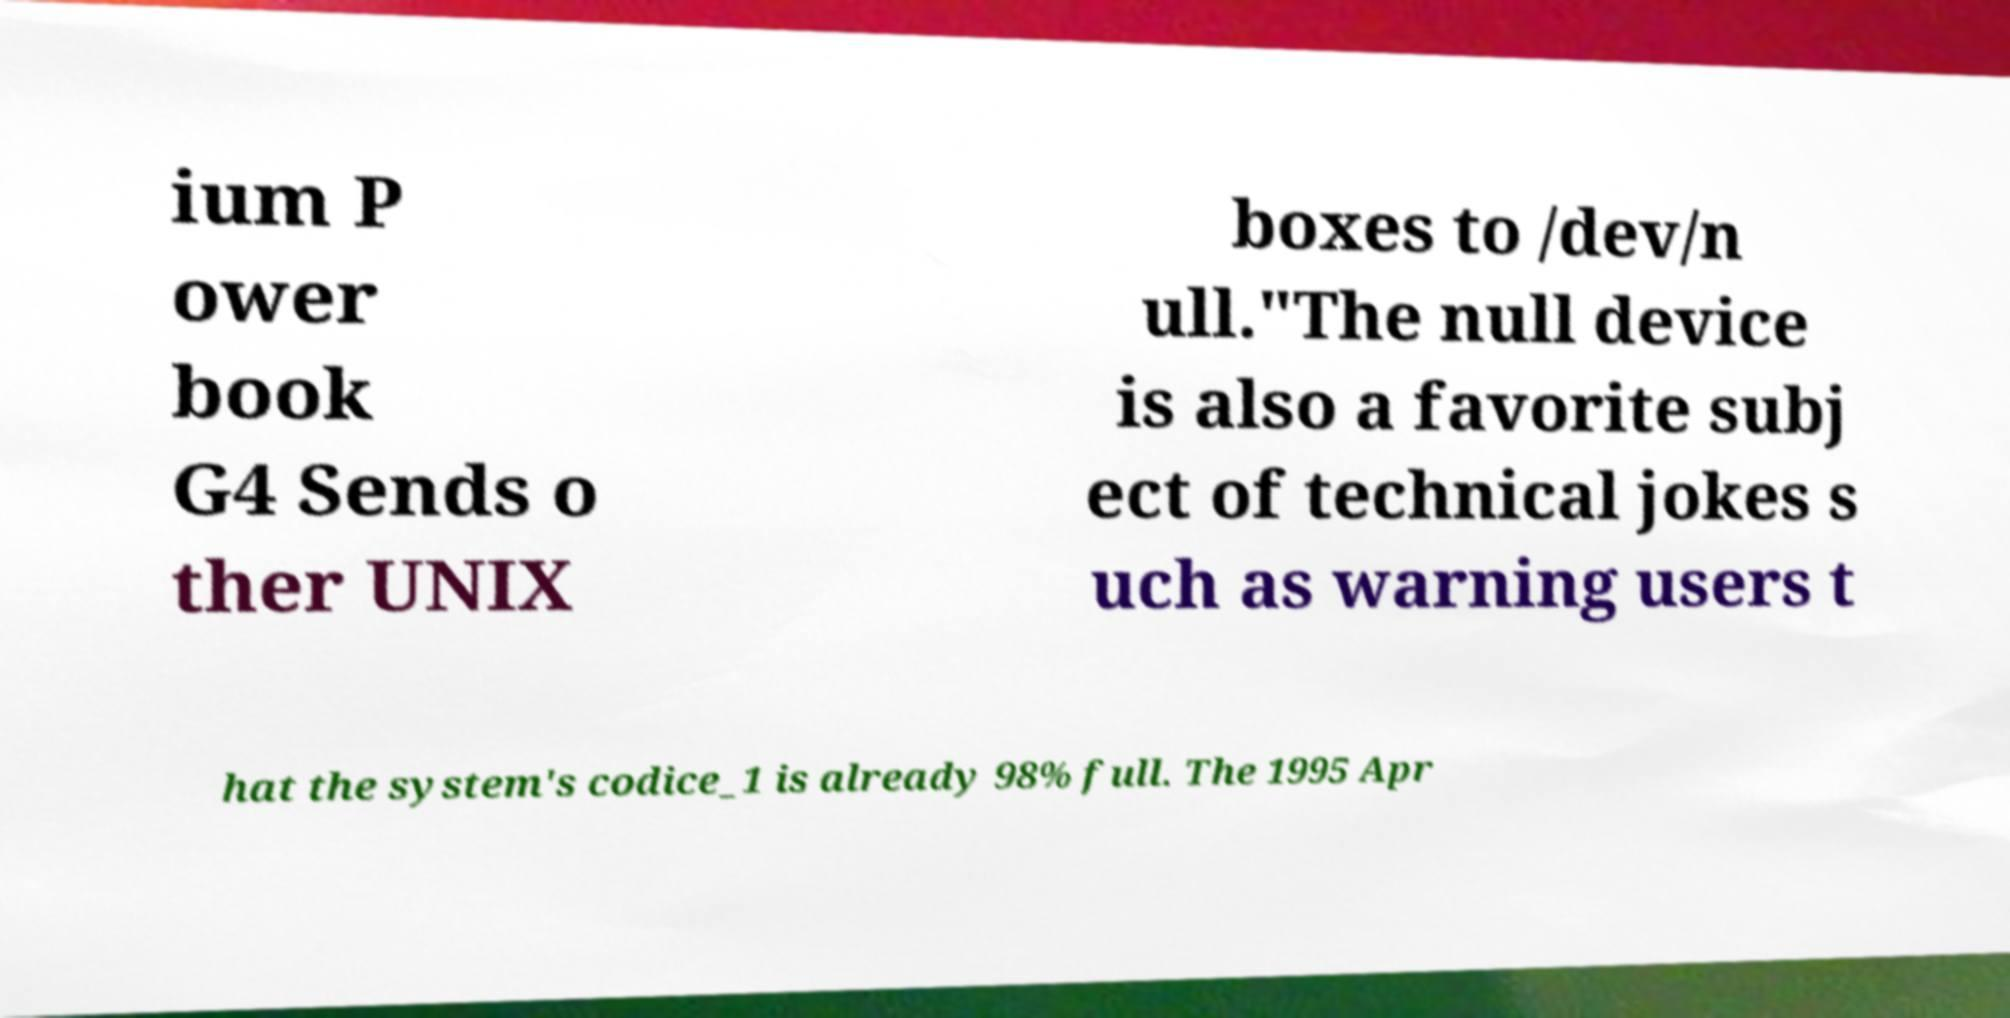Can you accurately transcribe the text from the provided image for me? ium P ower book G4 Sends o ther UNIX boxes to /dev/n ull."The null device is also a favorite subj ect of technical jokes s uch as warning users t hat the system's codice_1 is already 98% full. The 1995 Apr 